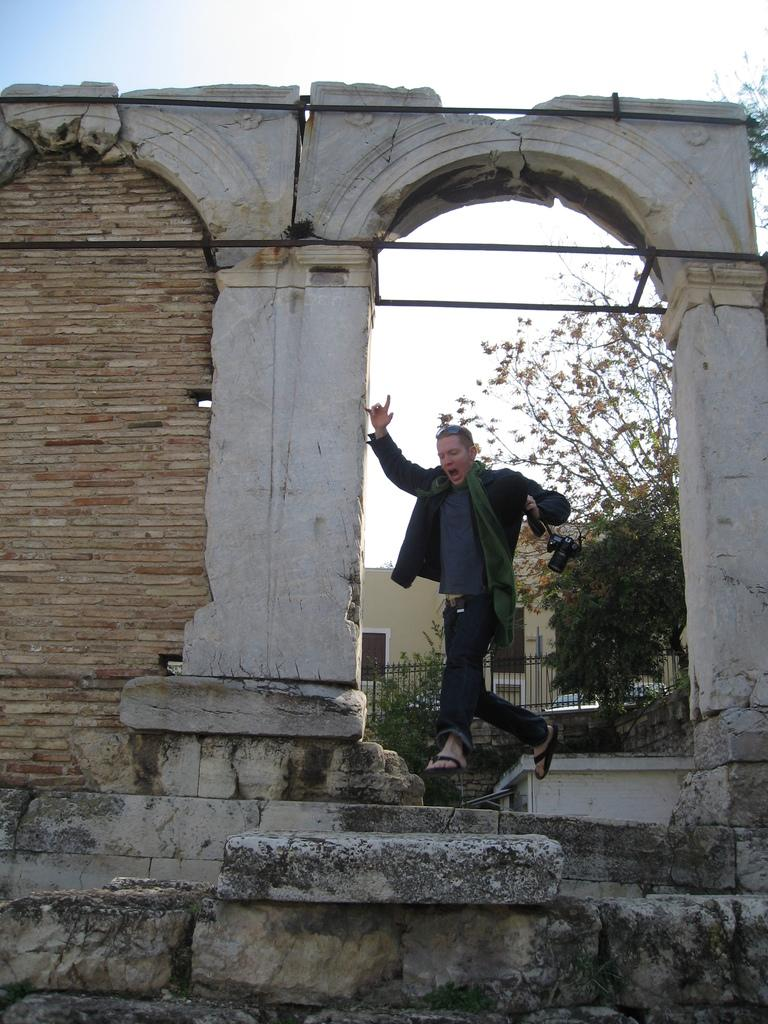Who is the main subject in the image? There is a man in the image. What is behind the man in the image? There is a wall behind the man. What architectural feature can be seen in the image? There is a railing in the image. What type of natural environment is visible in the image? Trees are visible in the image. What is visible in the background of the image? The sky is visible in the background of the image. How many sisters does the man have in the image? There is no information about the man's sisters in the image. 